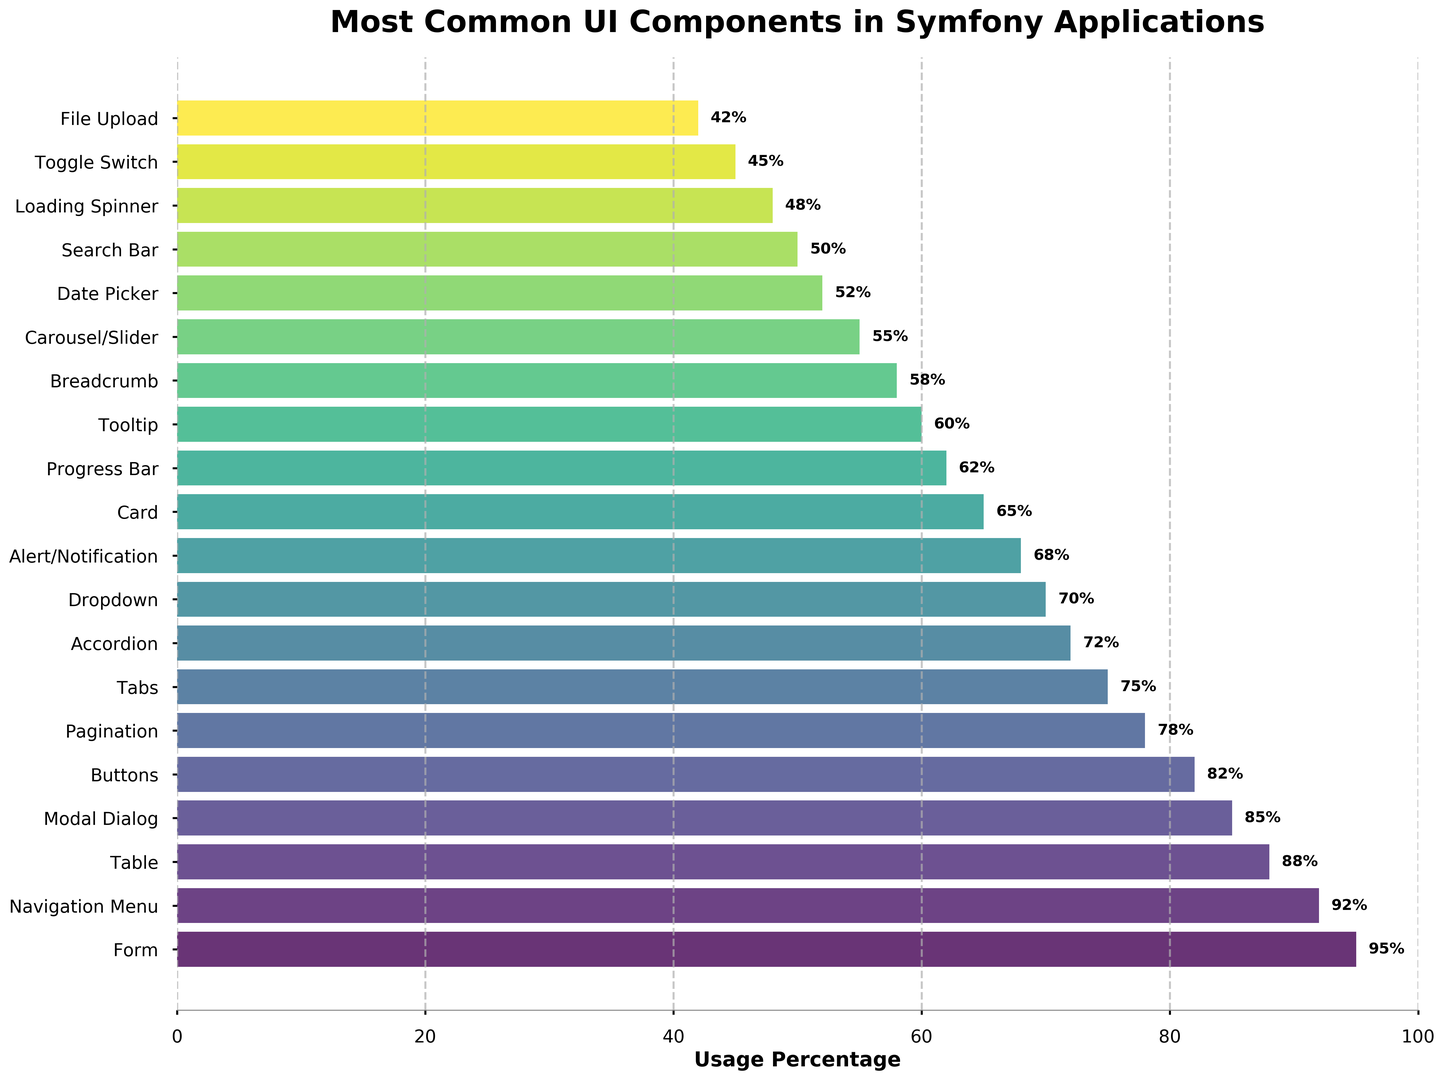Which UI component has the highest usage percentage? By looking at the bar chart, the component with the longest bar represents the highest usage percentage. This is the "Form" component.
Answer: Form How much more frequently is the Form component used compared to the Alert/Notification component? Find the usage percentages for both the Form and Alert/Notification components from the bar chart. The Form usage is 95%, and the Alert/Notification usage is 68%. Subtract the smaller value from the larger one: 95% - 68% = 27%.
Answer: 27% What is the combined usage percentage of the top three UI components? Identify the top three components by length of the bars: Form (95%), Navigation Menu (92%), and Table (88%). Add these percentages together: 95% + 92% + 88% = 275%.
Answer: 275% Are there any components with a usage percentage below 50%? Look for bars that do not extend past the 50% mark. The components below 50% usage are Loading Spinner (48%), Toggle Switch (45%), and File Upload (42%).
Answer: Yes Which component has a higher usage percentage: Modal Dialog or Pagination? Compare the bar lengths or the percentages directly. Modal Dialog has a usage percentage of 85%, while Pagination has 78%, so Modal Dialog has a higher usage percentage.
Answer: Modal Dialog What is the difference in usage percentage between the Buttons and the Card components? Find the usage percentages for both the Buttons and Card components from the bar chart. The Buttons usage is 82%, and the Card usage is 65%. Subtract the smaller value from the larger one: 82% - 65% = 17%.
Answer: 17% Which components have a usage percentage of exactly 60%? Look for the bar that extends to exactly 60%. The Tooltip component has a usage percentage of exactly 60%.
Answer: Tooltip Is the usage percentage of Date Picker closer to Breadcrumb or Toggle Switch? Compare the usages for Date Picker (52%), Breadcrumb (58%), and Toggle Switch (45%). The difference between Date Picker and Breadcrumb is 58% - 52% = 6%. The difference between Date Picker and Toggle Switch is 52% - 45% = 7%. Date Picker is closer to Breadcrumb as the difference is smaller (6% vs 7%).
Answer: Breadcrumb How many components have usage percentages between 70% and 90%? Identify bars whose lengths fall between the 70% and 90% marks. These components are Table (88%), Modal Dialog (85%), Buttons (82%), Pagination (78%), Tabs (75%), and Accordion (72%). Count them to get the total. There are 6 components.
Answer: 6 Which component most closely matches the visual attribute of having a 55% bar height? Look for the bar that corresponds closely to 55%. The Carousel/Slider component has a usage percentage of 55%.
Answer: Carousel/Slider 